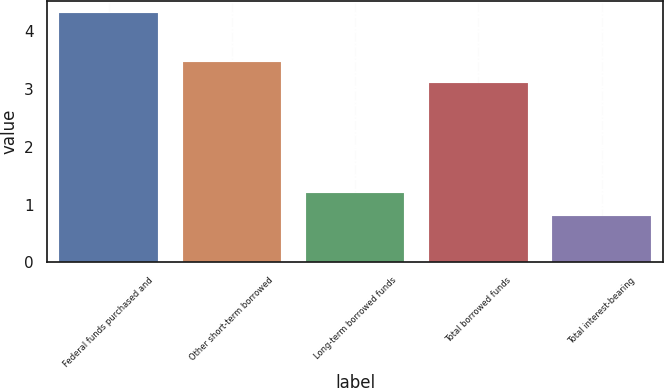<chart> <loc_0><loc_0><loc_500><loc_500><bar_chart><fcel>Federal funds purchased and<fcel>Other short-term borrowed<fcel>Long-term borrowed funds<fcel>Total borrowed funds<fcel>Total interest-bearing<nl><fcel>4.31<fcel>3.46<fcel>1.2<fcel>3.11<fcel>0.8<nl></chart> 